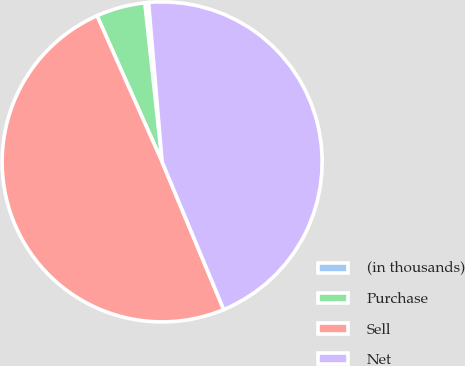Convert chart. <chart><loc_0><loc_0><loc_500><loc_500><pie_chart><fcel>(in thousands)<fcel>Purchase<fcel>Sell<fcel>Net<nl><fcel>0.38%<fcel>4.94%<fcel>49.62%<fcel>45.06%<nl></chart> 